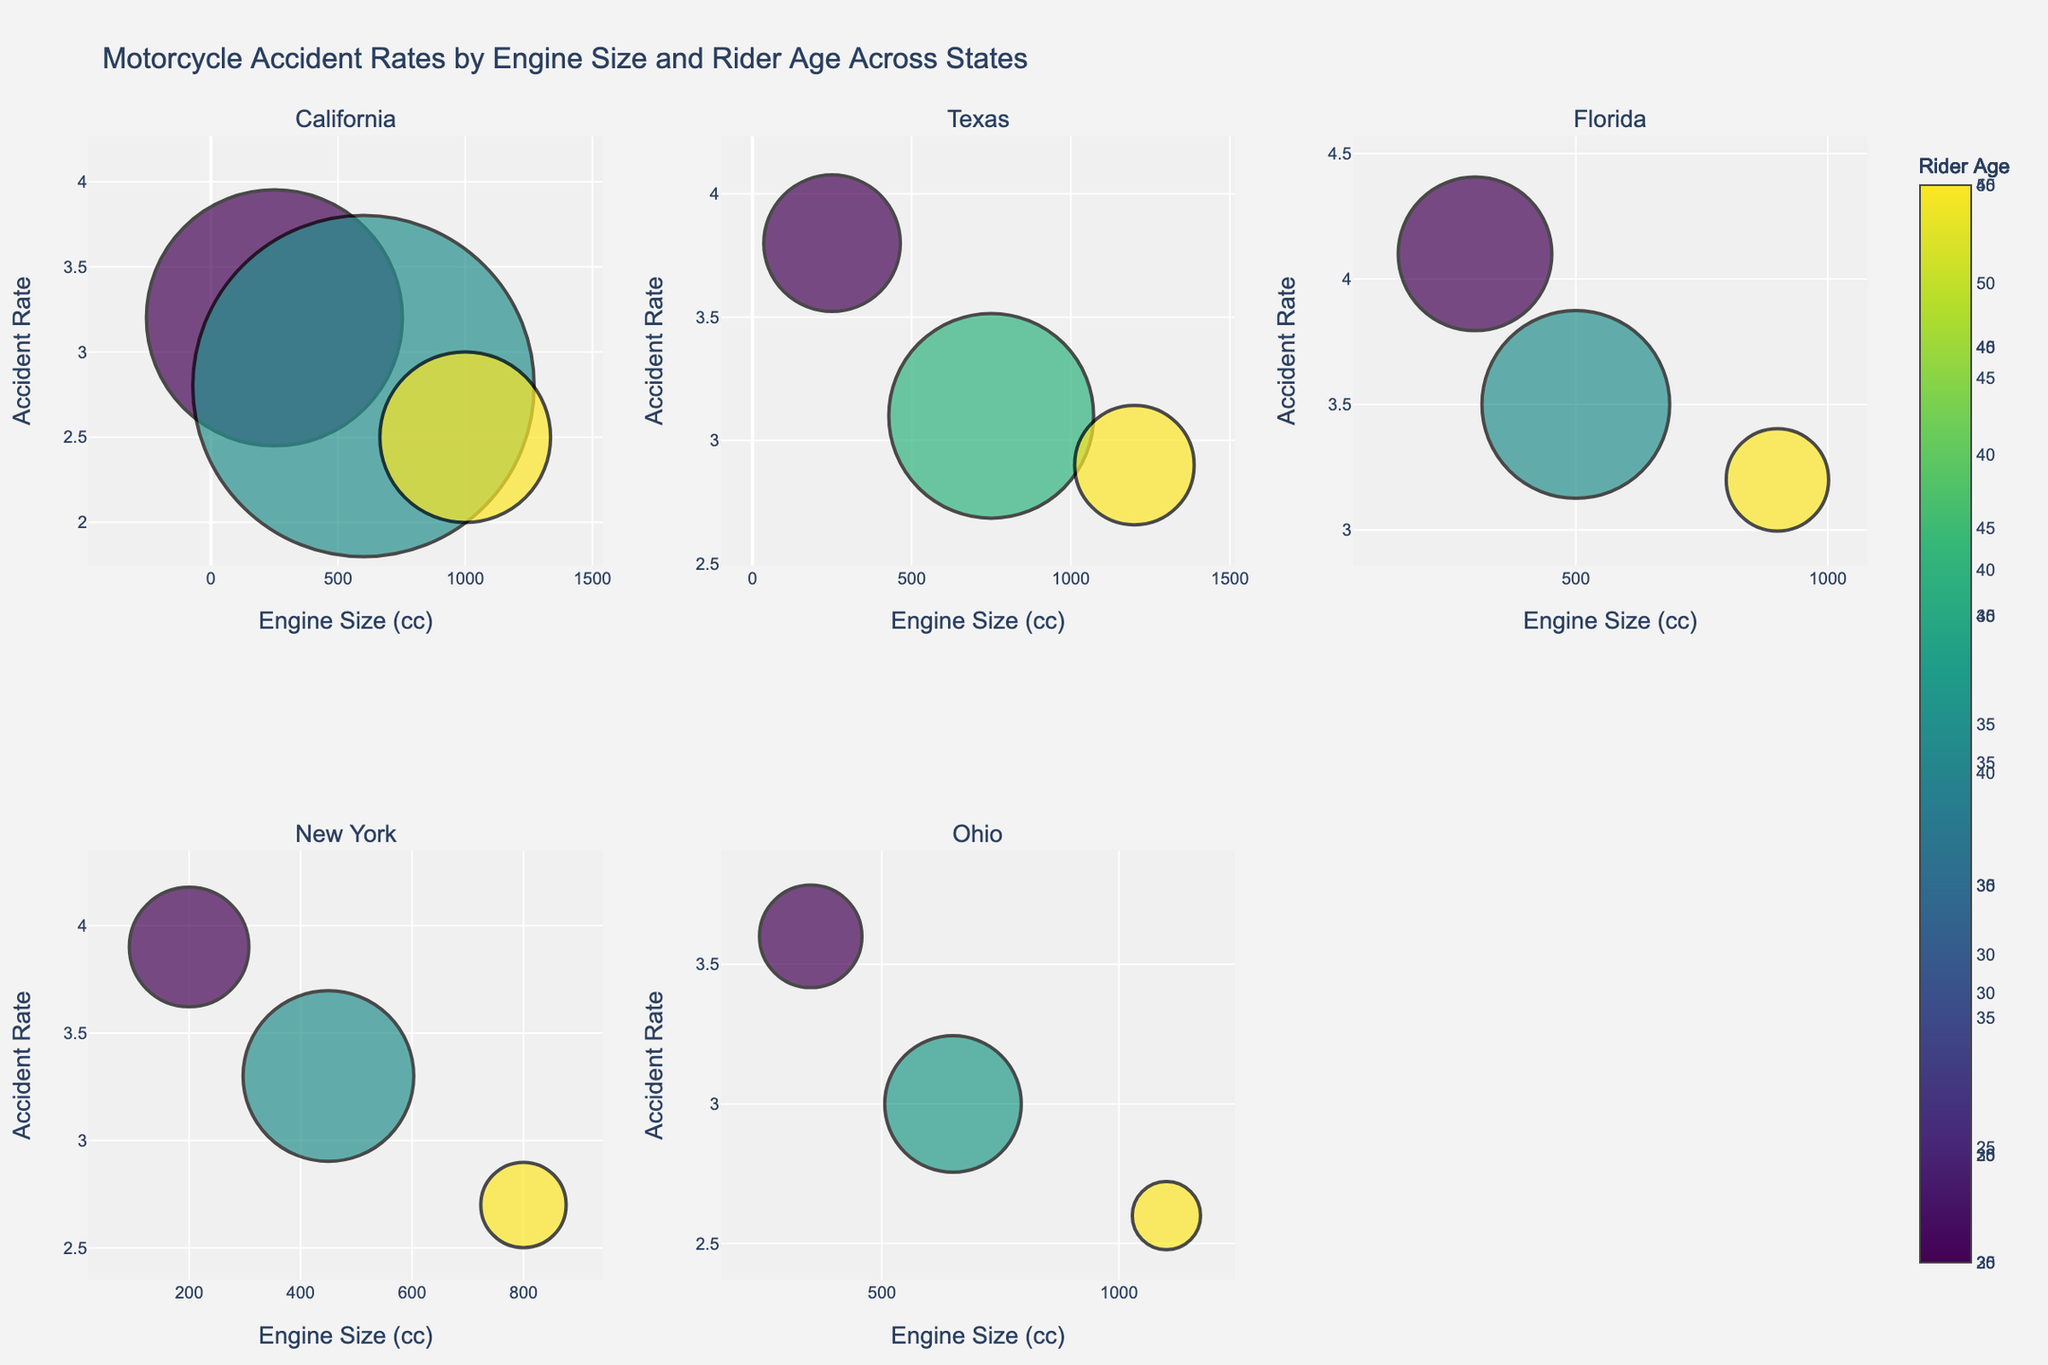1. What is the title of the figure? The title can usually be found at the top of the figure, providing a general description of what the figure depicts. In this case, it should be seen at the top center.
Answer: Motorcycle Accident Rates by Engine Size and Rider Age Across States 2. How many subplots are present in the figure? The figure is divided into grids, with each grid representing a subplot assigned to different states. By counting these grids, one can determine the number of subplots.
Answer: 6 3. Which state has the highest accident rate for any engine size depicted in the subplot? By examining all the subplots, we look for the highest y-axis value (accident rate) across all engine sizes.
Answer: Florida 4. Which two states have the closest accident rates for the smallest engine size? To find this, compare the accident rates of the smallest engine size in each state's subplot and identify the two states with the closest values.
Answer: California and New York 5. What is the relationship between engine size and accident rate in Florida? Analyzing the subplot for Florida involves observing the trend of accident rates as engine size increases.
Answer: The accident rate generally decreases with increasing engine size 6. How does the accident rate for 250cc engines in Texas compare to California? Find the 250cc engine data points in both Texas and California subplots, then compare the y-axis values (accident rates).
Answer: Texas has a higher accident rate 7. For which state does a higher rider age generally correspond to a lower accident rate? Examine each subplot and observe the color gradient (representing rider age) in correlation with the accident rate (y-axis).
Answer: California 8. How does the size of the bubbles change with the number of total riders in New York? In New York's subplot, observe the bubbles' sizes and note the general trend as the number of riders increases.
Answer: The bubble size increases with the number of total riders 9. Which state shows the smallest difference in accident rates across different engine sizes? Evaluate the variability in the y-axis values (accident rates) for different engine sizes in each state subplot to find the state with minimal differences.
Answer: Ohio 10. What can be inferred about the accident rate for 1000cc engines across the states? For each subplot, identify the accident rate for 1000cc engines and compare values to draw an inference.
Answer: Accident rates tend to be lower for 1000cc engines across all states 